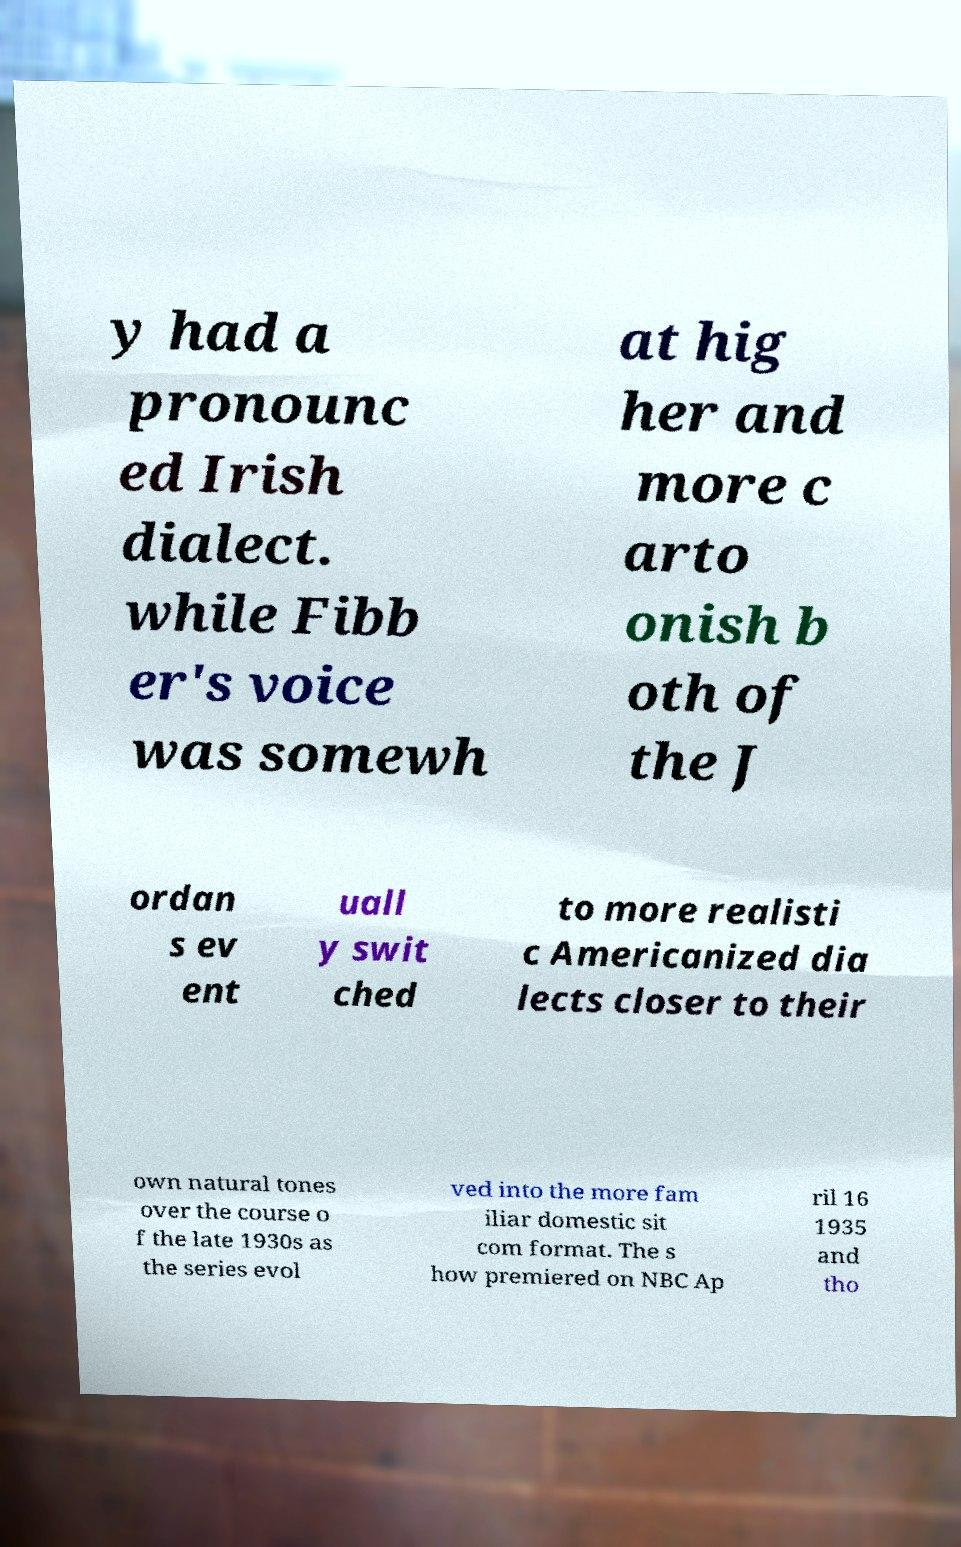I need the written content from this picture converted into text. Can you do that? y had a pronounc ed Irish dialect. while Fibb er's voice was somewh at hig her and more c arto onish b oth of the J ordan s ev ent uall y swit ched to more realisti c Americanized dia lects closer to their own natural tones over the course o f the late 1930s as the series evol ved into the more fam iliar domestic sit com format. The s how premiered on NBC Ap ril 16 1935 and tho 